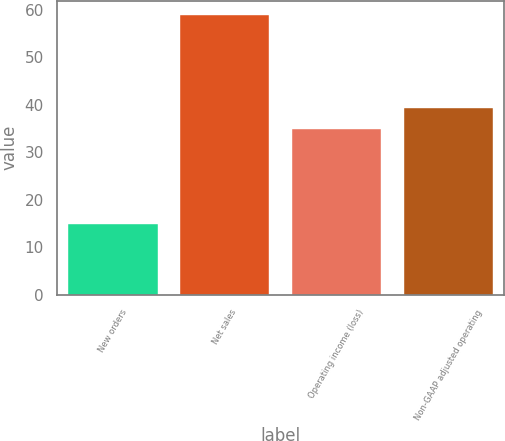Convert chart to OTSL. <chart><loc_0><loc_0><loc_500><loc_500><bar_chart><fcel>New orders<fcel>Net sales<fcel>Operating income (loss)<fcel>Non-GAAP adjusted operating<nl><fcel>15<fcel>59<fcel>35<fcel>39.4<nl></chart> 